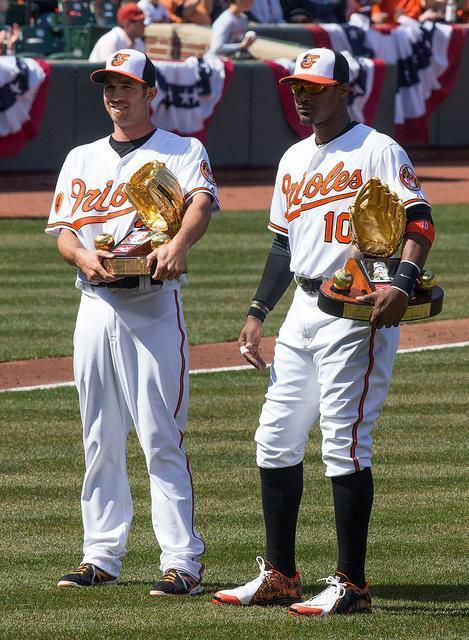How many baseball gloves are in the picture?
Give a very brief answer. 2. How many people are there?
Give a very brief answer. 3. How many black dog in the image?
Give a very brief answer. 0. 